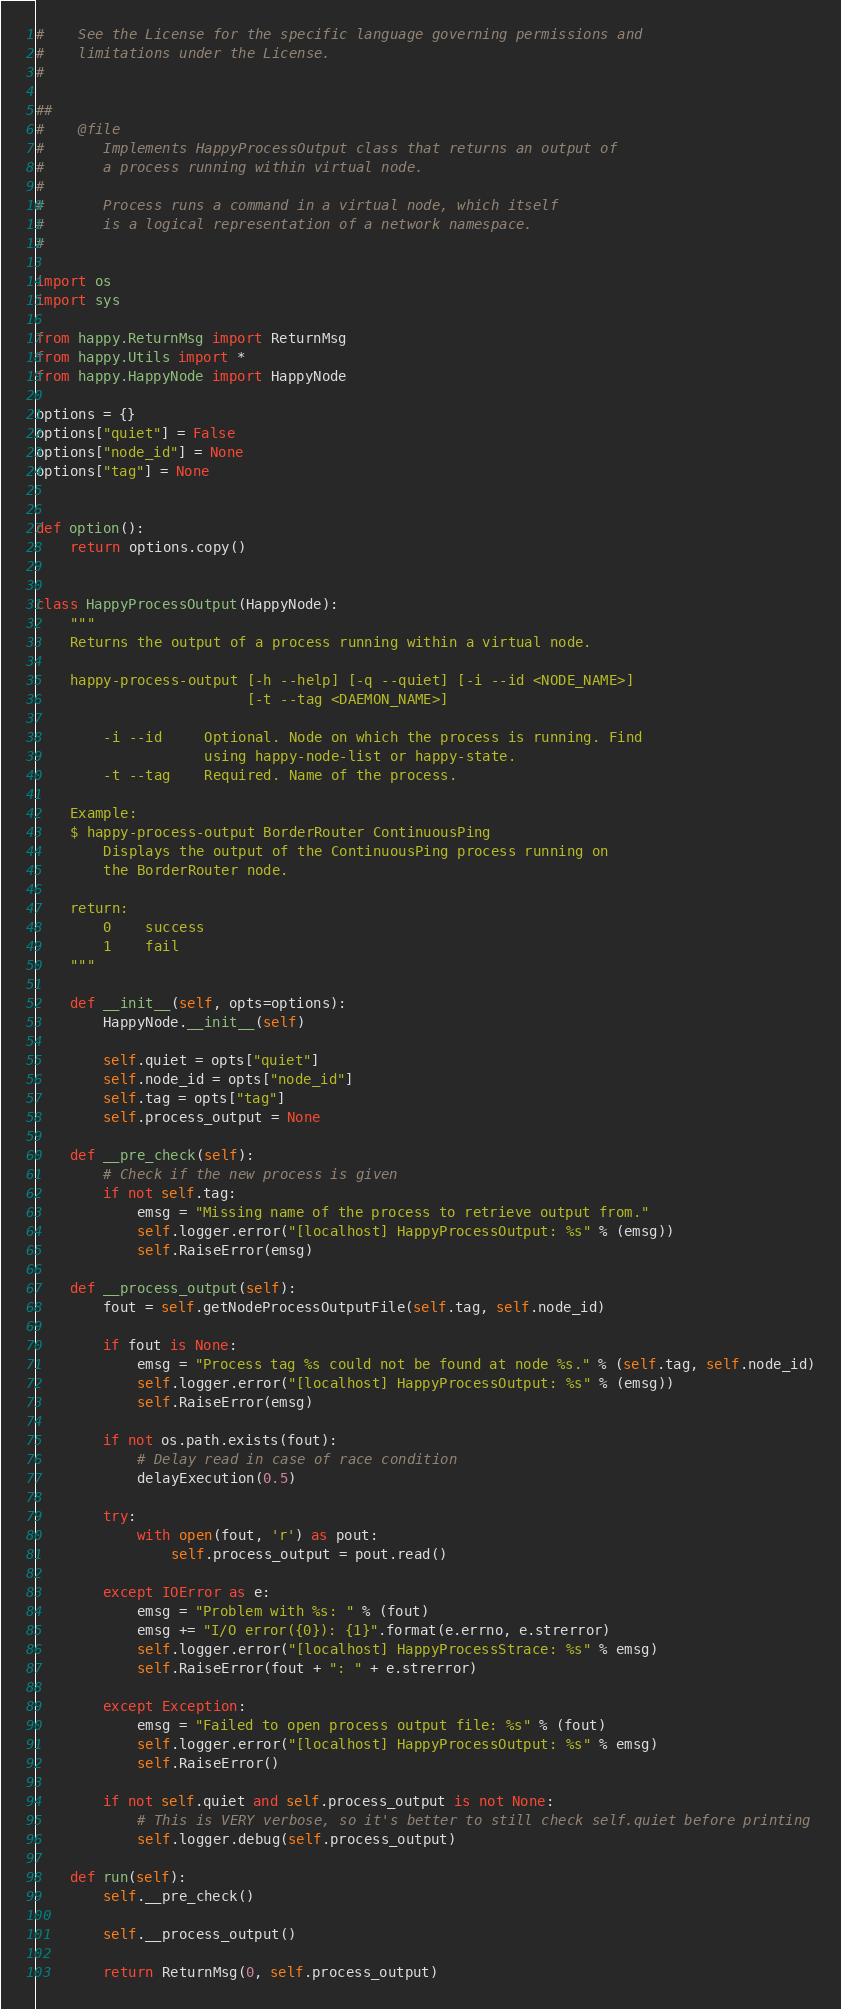<code> <loc_0><loc_0><loc_500><loc_500><_Python_>#    See the License for the specific language governing permissions and
#    limitations under the License.
#

##
#    @file
#       Implements HappyProcessOutput class that returns an output of
#       a process running within virtual node.
#
#       Process runs a command in a virtual node, which itself
#       is a logical representation of a network namespace.
#

import os
import sys

from happy.ReturnMsg import ReturnMsg
from happy.Utils import *
from happy.HappyNode import HappyNode

options = {}
options["quiet"] = False
options["node_id"] = None
options["tag"] = None


def option():
    return options.copy()


class HappyProcessOutput(HappyNode):
    """
    Returns the output of a process running within a virtual node.

    happy-process-output [-h --help] [-q --quiet] [-i --id <NODE_NAME>]
                         [-t --tag <DAEMON_NAME>]

        -i --id     Optional. Node on which the process is running. Find
                    using happy-node-list or happy-state.
        -t --tag    Required. Name of the process.

    Example:
    $ happy-process-output BorderRouter ContinuousPing
        Displays the output of the ContinuousPing process running on
        the BorderRouter node.

    return:
        0    success
        1    fail
    """

    def __init__(self, opts=options):
        HappyNode.__init__(self)

        self.quiet = opts["quiet"]
        self.node_id = opts["node_id"]
        self.tag = opts["tag"]
        self.process_output = None

    def __pre_check(self):
        # Check if the new process is given
        if not self.tag:
            emsg = "Missing name of the process to retrieve output from."
            self.logger.error("[localhost] HappyProcessOutput: %s" % (emsg))
            self.RaiseError(emsg)

    def __process_output(self):
        fout = self.getNodeProcessOutputFile(self.tag, self.node_id)

        if fout is None:
            emsg = "Process tag %s could not be found at node %s." % (self.tag, self.node_id)
            self.logger.error("[localhost] HappyProcessOutput: %s" % (emsg))
            self.RaiseError(emsg)

        if not os.path.exists(fout):
            # Delay read in case of race condition
            delayExecution(0.5)

        try:
            with open(fout, 'r') as pout:
                self.process_output = pout.read()

        except IOError as e:
            emsg = "Problem with %s: " % (fout)
            emsg += "I/O error({0}): {1}".format(e.errno, e.strerror)
            self.logger.error("[localhost] HappyProcessStrace: %s" % emsg)
            self.RaiseError(fout + ": " + e.strerror)

        except Exception:
            emsg = "Failed to open process output file: %s" % (fout)
            self.logger.error("[localhost] HappyProcessOutput: %s" % emsg)
            self.RaiseError()

        if not self.quiet and self.process_output is not None:
            # This is VERY verbose, so it's better to still check self.quiet before printing
            self.logger.debug(self.process_output)

    def run(self):
        self.__pre_check()

        self.__process_output()

        return ReturnMsg(0, self.process_output)
</code> 